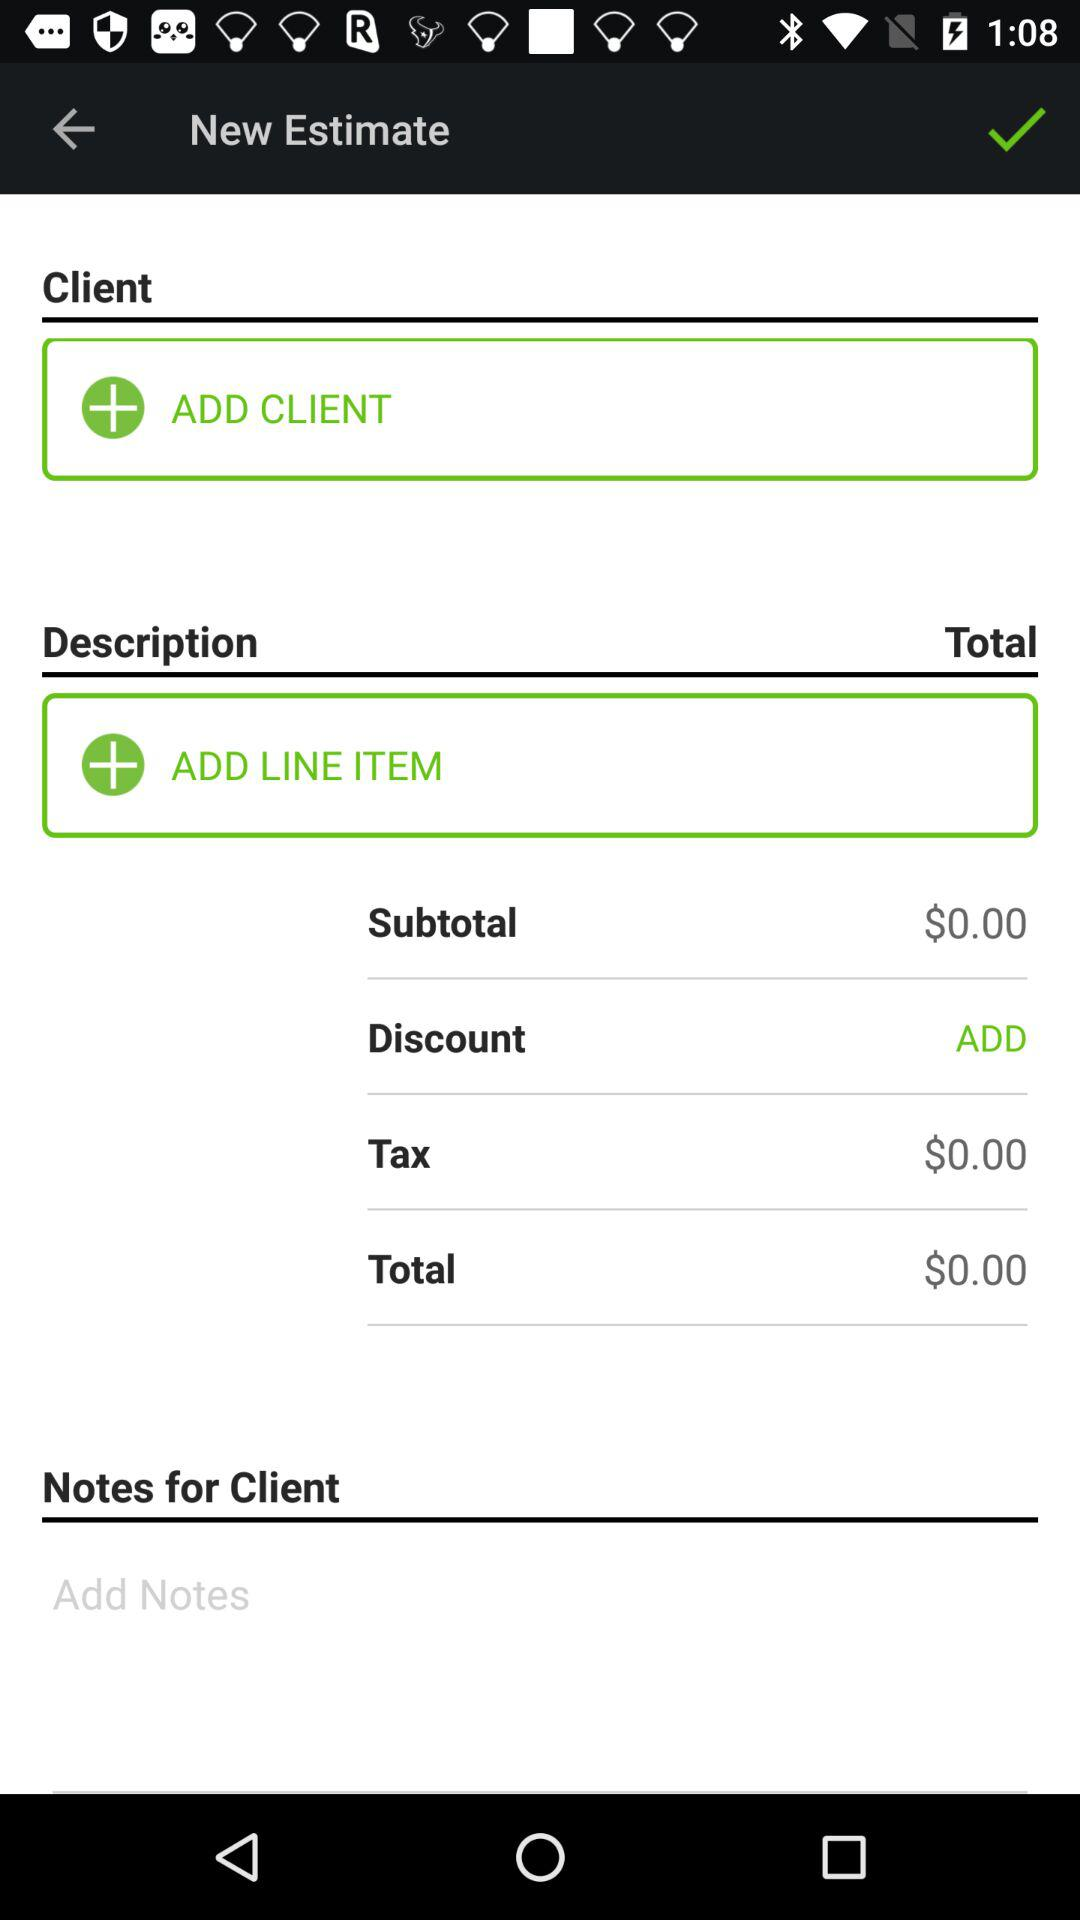What's the total sum? The total sum is $0.00. 